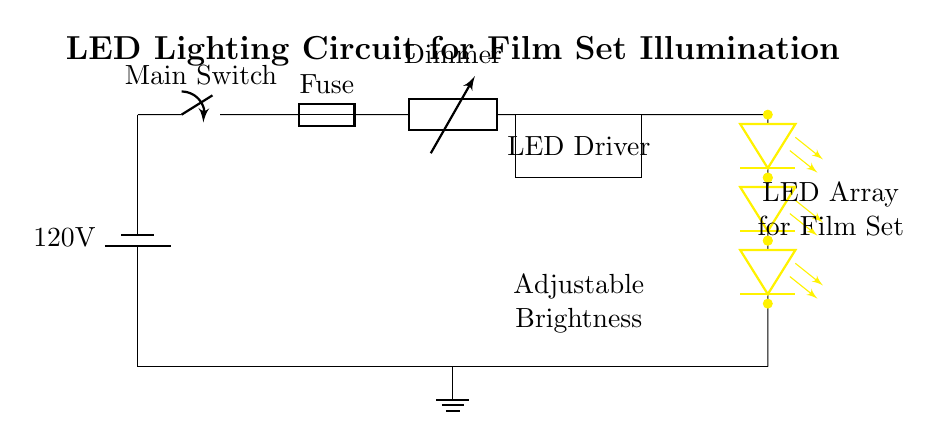What is the type of power source used in this circuit? The circuit uses a battery source, as indicated by the symbol representing a battery. The label specifies a voltage of 120 volts.
Answer: battery What component is used to control the brightness of the LED lights? The dimmer is the component that adjusts the brightness levels of the LED array by changing the resistance in the circuit, which affects the power delivered to the LEDs.
Answer: dimmer How many LED devices are represented in the circuit? The circuit shows a total of four LED devices connected in series to create the LED array, each represented by the LED symbol.
Answer: four What component immediately follows the fuse in the circuit? The dimmer component is the next one in sequence following the fuse, highlighting its role in managing the power delivery after the protective fuse.
Answer: dimmer What is the purpose of the fuse in this circuit? The fuse serves to protect the circuit from excessive current by breaking the circuit if the current exceeds a certain level, thus preventing damage to the components.
Answer: protective device What does the rectangle labeled "LED Driver" represent? The rectangle indicates the LED driver, a crucial component that supplies and regulates the required current and voltage for the LED array to function properly.
Answer: LED Driver What is the total grounding point for the circuit? The ground is represented at the bottom of the circuit, where all negative connections converge, ensuring safety and stability in the circuit operation.
Answer: ground 